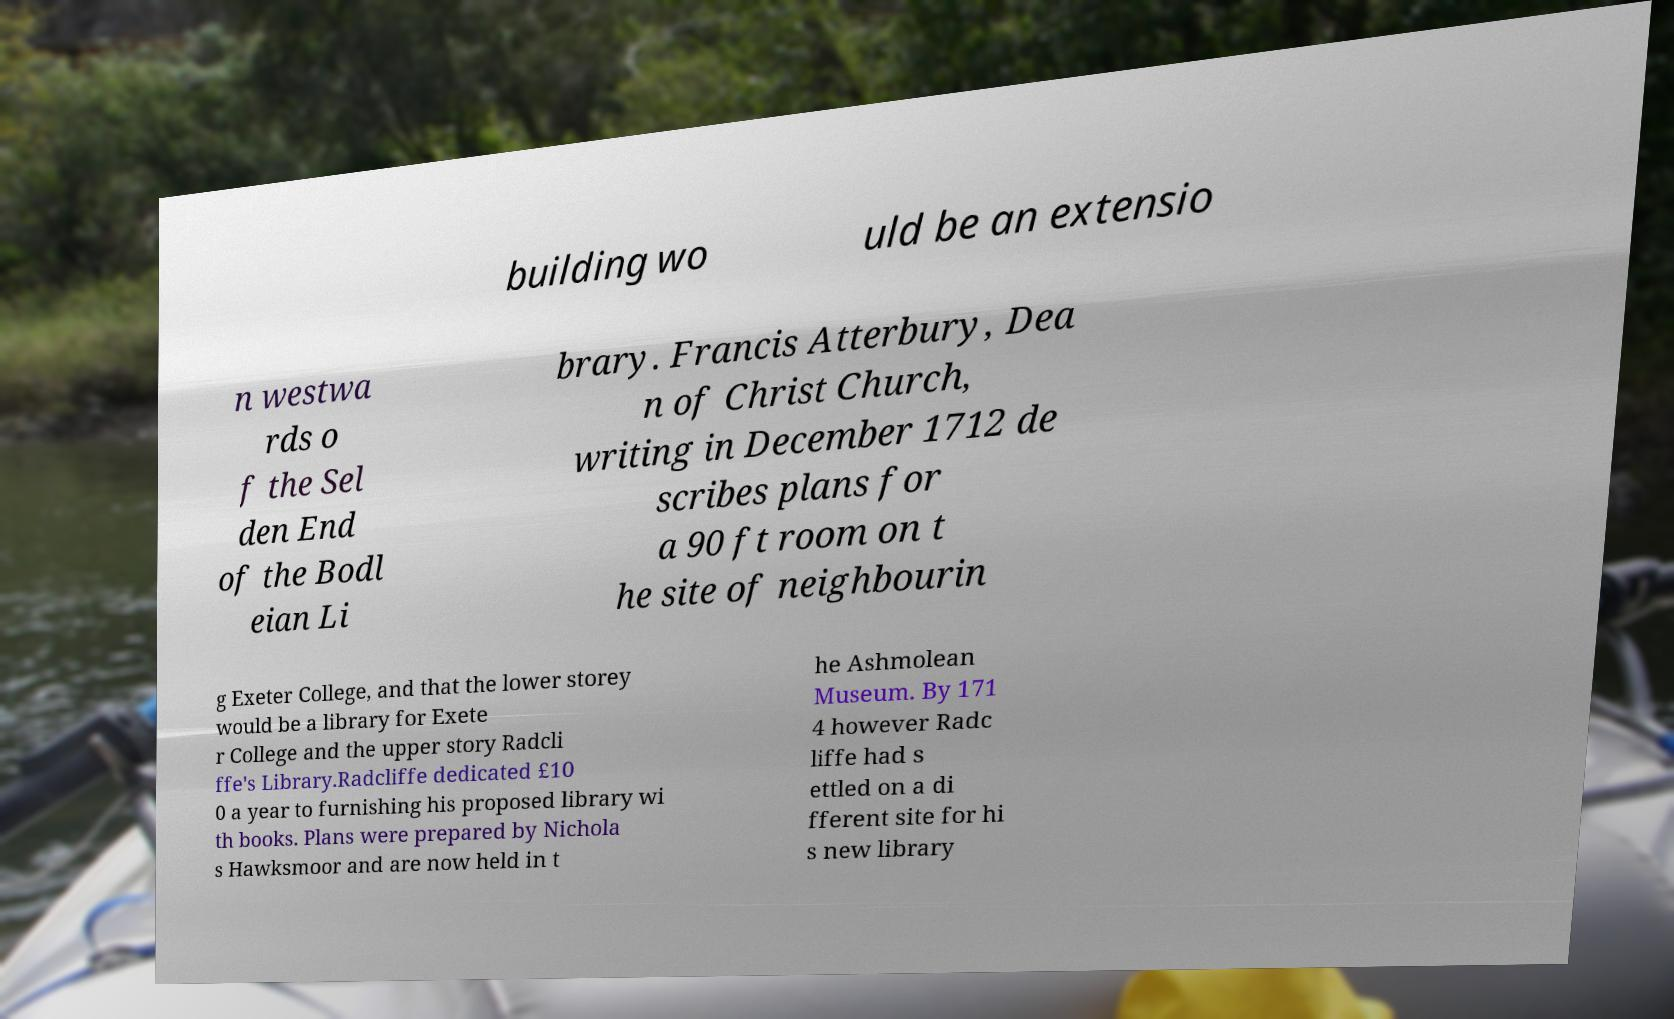Can you read and provide the text displayed in the image?This photo seems to have some interesting text. Can you extract and type it out for me? building wo uld be an extensio n westwa rds o f the Sel den End of the Bodl eian Li brary. Francis Atterbury, Dea n of Christ Church, writing in December 1712 de scribes plans for a 90 ft room on t he site of neighbourin g Exeter College, and that the lower storey would be a library for Exete r College and the upper story Radcli ffe's Library.Radcliffe dedicated £10 0 a year to furnishing his proposed library wi th books. Plans were prepared by Nichola s Hawksmoor and are now held in t he Ashmolean Museum. By 171 4 however Radc liffe had s ettled on a di fferent site for hi s new library 